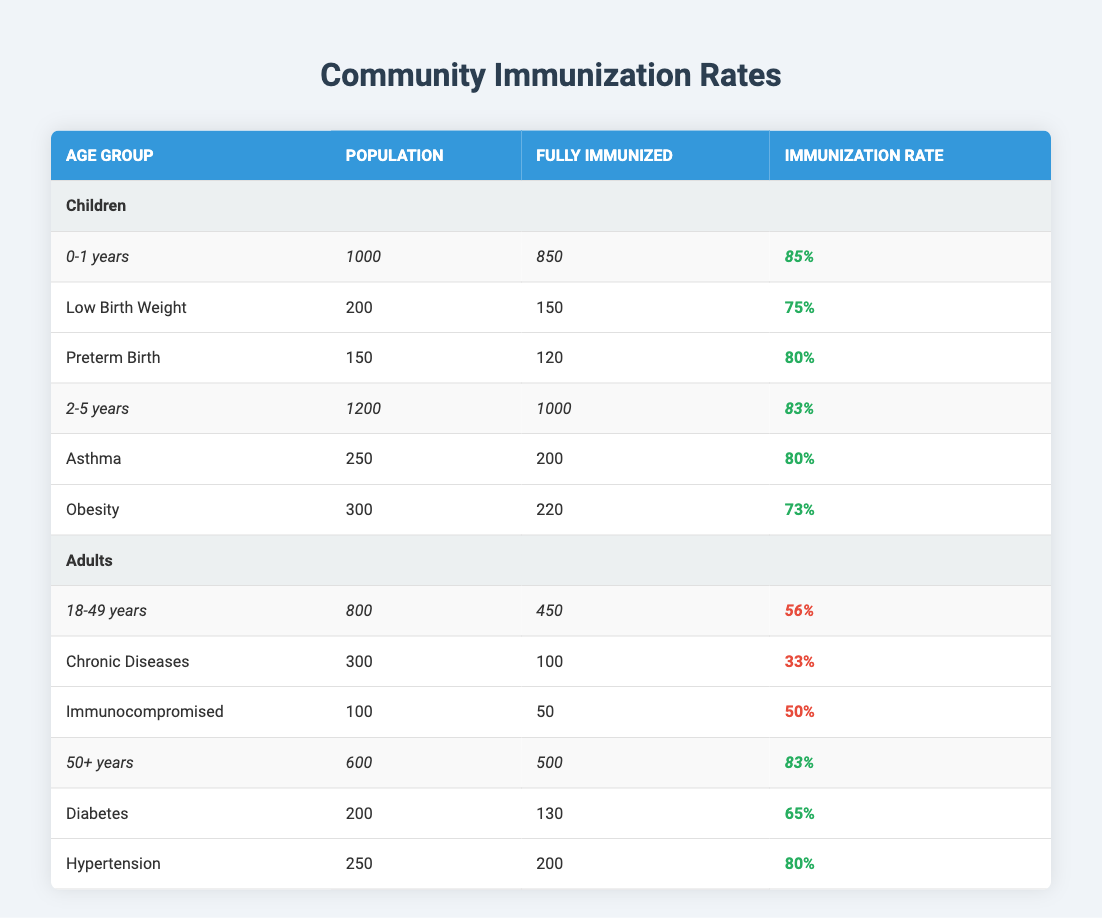What is the immunization rate for children aged 0-1 years? The immunization rate is calculated as the number of fully immunized children divided by the total population for that age group. For children aged 0-1 years, 850 out of 1000 are fully immunized, so the rate is 850 / 1000 = 0.85, which is 85%.
Answer: 85% How many adults aged 18-49 years are fully immunized? The table shows that for adults aged 18-49 years, there are 450 adults listed as fully immunized.
Answer: 450 What is the difference in the immunization rates between children aged 2-5 years and adults aged 18-49 years? The immunization rate for children aged 2-5 years is 83%, and for adults aged 18-49 years, it is 56%. The difference is 83% - 56% = 27%.
Answer: 27% Is the immunization rate for individuals with chronic diseases higher than that for those who are immunocompromised? The immunization rate for those with chronic diseases is 100 out of 300, which is 33%, while for the immunocompromised it is 50 out of 100, which is 50%. Since 50% is higher than 33%, the statement is true.
Answer: Yes What is the total population of children in the given data? To find the total population of children, we sum the total population for both age groups: 1000 (0-1 years) + 1200 (2-5 years) = 2200.
Answer: 2200 What percentage of children aged 2-5 years with obesity are fully immunized? For children aged 2-5 years, 220 out of 300 with obesity are fully immunized. The percentage is (220 / 300) * 100 = 73.33%, which rounds to 73%.
Answer: 73% What is the average immunization rate for the adults in the 50+ years age group? For the 50+ age group, the immunization rates are 65% for diabetes and 80% for hypertension. The average is (65% + 80%) / 2 = 72.5%.
Answer: 72.5% Are there more children in the 0-1 year age group who are fully immunized compared to adults in the 18-49 year age group? There are 850 children fully immunized in the 0-1 year group and 450 adults fully immunized in the 18-49 group. Since 850 is greater than 450, the statement is true.
Answer: Yes 